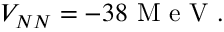<formula> <loc_0><loc_0><loc_500><loc_500>V _ { N N } = - 3 8 M e V .</formula> 